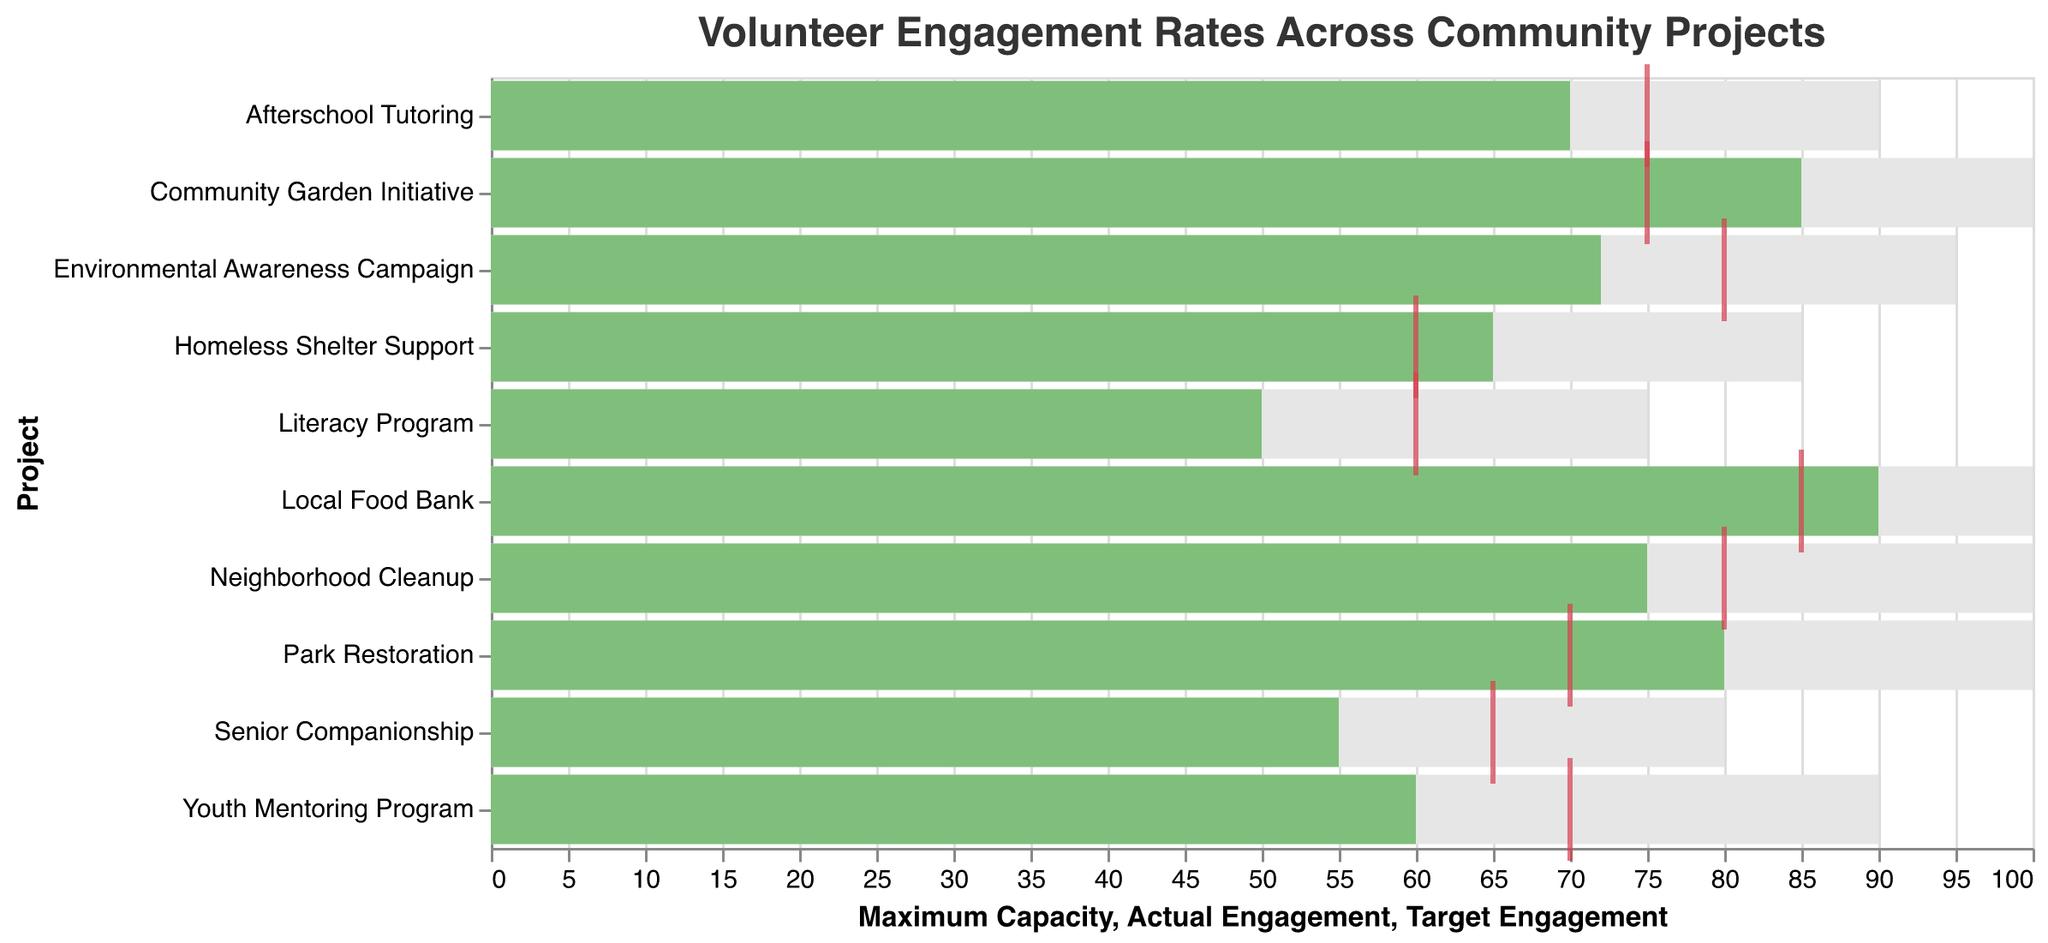What is the title of the chart? The title is typically located at the top of the chart and describes the main purpose or insight being visualized.
Answer: Volunteer Engagement Rates Across Community Projects Which project has the highest actual engagement rate? By examining the bar lengths representing actual engagement, the project with the longest bar has the highest actual engagement rate.
Answer: Local Food Bank How many projects have an actual engagement rate higher than their target engagement rate? Compare the actual engagement bars and the target engagement ticks for each project. Count the number of projects where the actual engagement bar surpasses the target engagement tick. This occurs with three projects: Community Garden Initiative, Local Food Bank, and Park Restoration.
Answer: 3 Which project has the lowest actual engagement rate compared to its target engagement rate? Identify the project with the largest negative gap between its actual engagement bar and target engagement tick. This would be the Literacy Program, as it shows a difference of 10 points (50 actual vs. 60 target).
Answer: Literacy Program Are there any projects where the actual engagement rate meets the target engagement rate? Look for any bars where the actual engagement aligns exactly with the position of the target engagement tick. None of the projects have their actual engagement equal to their target engagement rate.
Answer: No What is the difference between the maximum capacity and actual engagement for Neighborhood Cleanup? Subtract the actual engagement value from the maximum capacity value for Neighborhood Cleanup: 100 - 75 = 25.
Answer: 25 Which project has the closest actual engagement rate to its target engagement rate without exceeding it? Calculate the difference between actual and target engagements for each project and identify the smallest positive difference. The Senior Companionship program has a difference of 10 (55 actual vs. 65 target), which is the closest without exceeding.
Answer: Senior Companionship Which two projects have the closest actual engagement rates to each other? Identify the two projects with the smallest absolute difference in their actual engagement values. The closest actual engagements are for Youth Mentoring Program (60) and Homeless Shelter Support (65), with a difference of 5.
Answer: Youth Mentoring Program and Homeless Shelter Support What is the total actual engagement for all the projects combined? Sum up the actual engagement values for all the projects: 75 + 60 + 85 + 55 + 90 + 70 + 80 + 65 + 50 + 72 = 702.
Answer: 702 